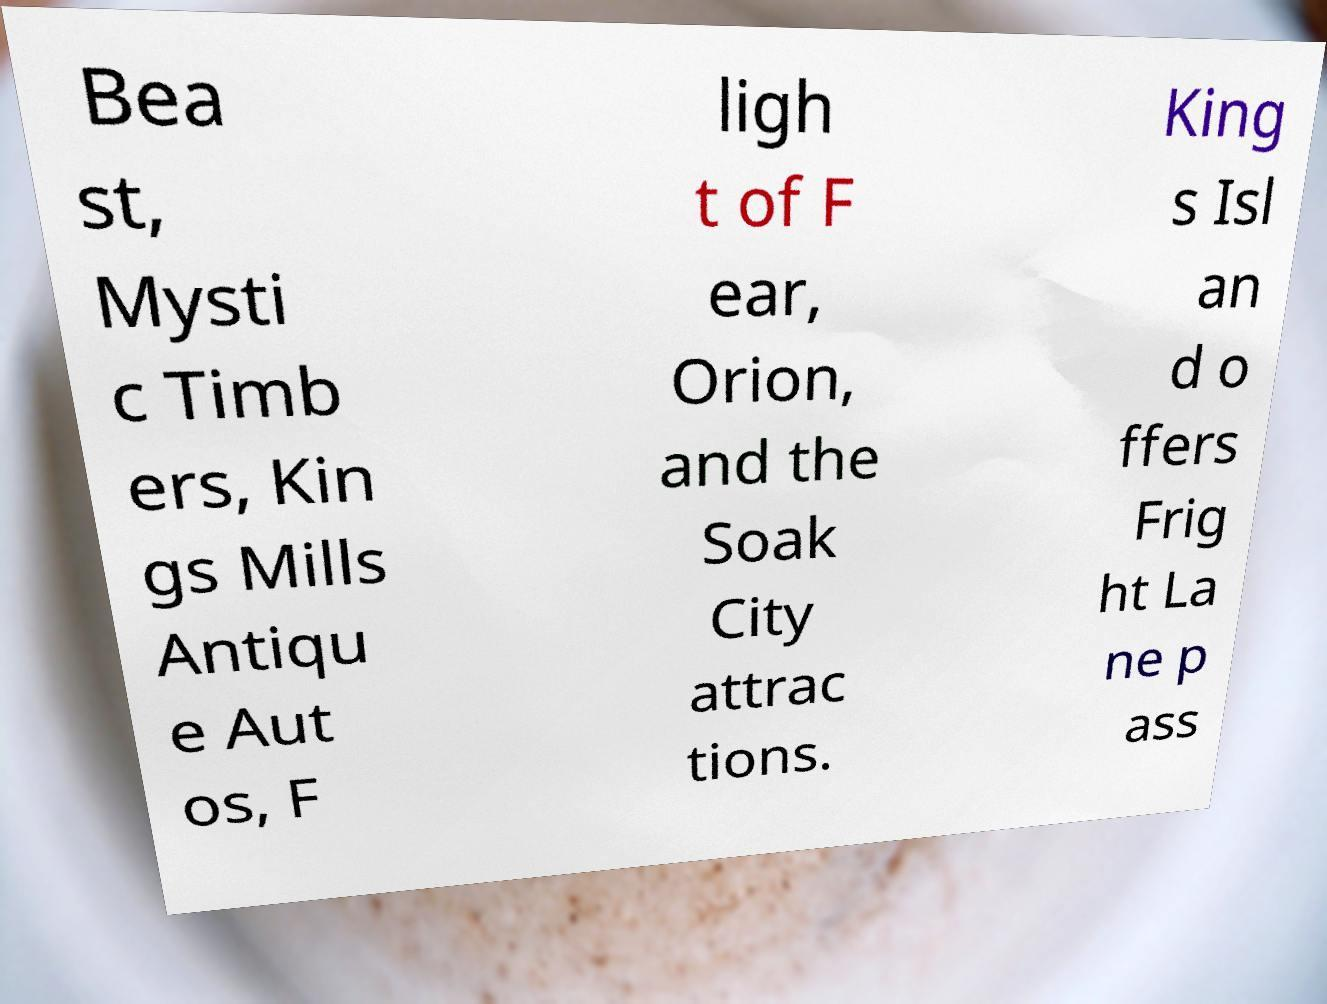Could you assist in decoding the text presented in this image and type it out clearly? Bea st, Mysti c Timb ers, Kin gs Mills Antiqu e Aut os, F ligh t of F ear, Orion, and the Soak City attrac tions. King s Isl an d o ffers Frig ht La ne p ass 